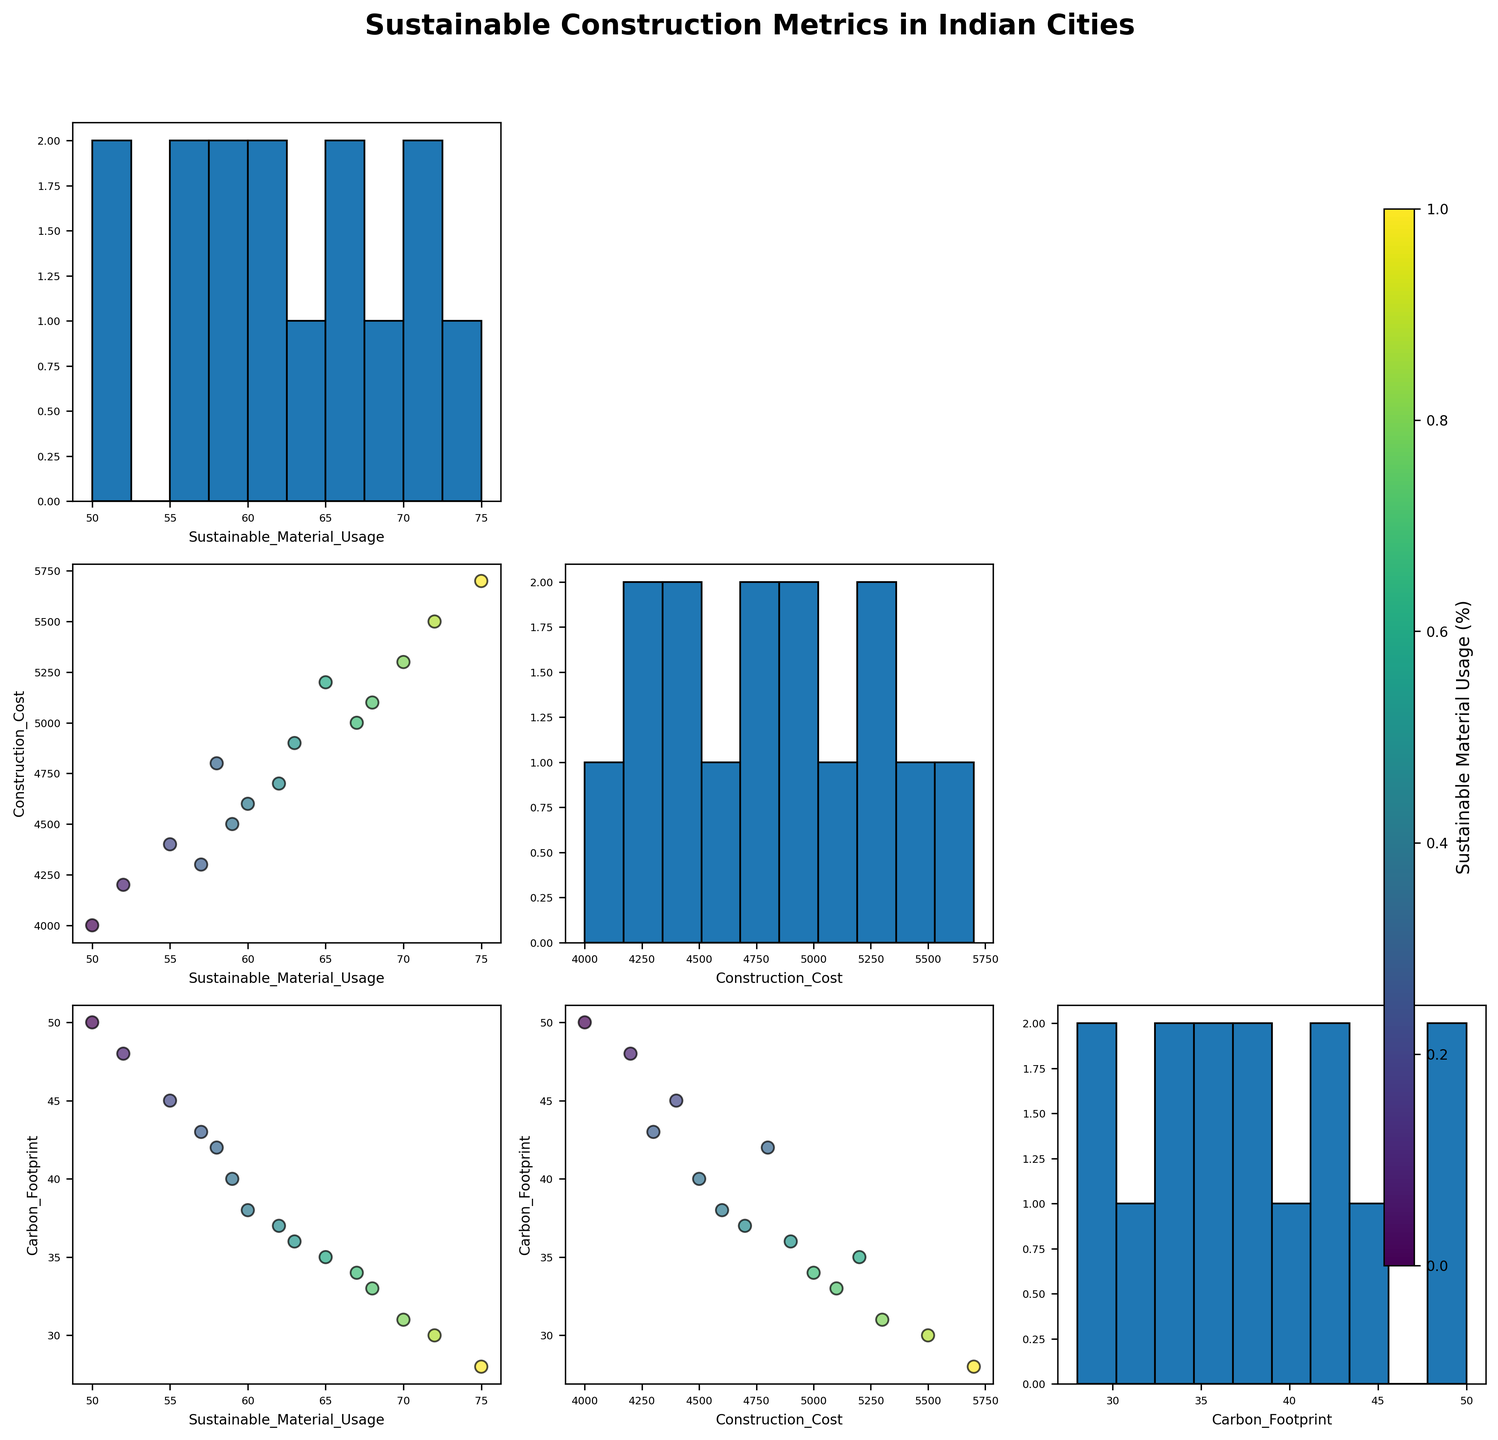What is the title of the figure? The title is usually mentioned at the top of the figure. In this case, it is "Sustainable Construction Metrics in Indian Cities".
Answer: Sustainable Construction Metrics in Indian Cities Which variable is represented by the color in the scatter plots? The color bar, shown separately with a label, indicates 'Sustainable Material Usage (%)'.
Answer: Sustainable Material Usage (%) How many cities are included in the dataset? By observing the figure, we can count the number of points or annotations (city names) present in the scatter plots. The figure has 15 cities labeled, from Mumbai to Nagpur.
Answer: 15 What is the scatter plot in the second row and the first column illustrating? The scatter plot in this position shows 'Construction Cost(INR/sqft)' on the x-axis and 'Sustainable Material Usage(%)' on the y-axis.
Answer: Construction Cost vs. Sustainable Material Usage Which city has the highest 'Sustainable Material Usage(%)' and what is its value? By looking at the color intensity corresponding to the highest value in the scatter plots or by identifying the outlier in histograms, Chandigarh has the highest 'Sustainable Material Usage' of 75%.
Answer: Chandigarh, 75% Is there a general trend between 'Construction Cost(INR/sqft)' and 'Carbon Footprint(kgCO2e/sqft)'? By observing the scatter plot for these two variables, it seems there is a positive correlation where higher construction costs tend to be associated with higher carbon footprints.
Answer: Positive correlation Which city has the lowest 'Carbon Footprint(kgCO2e/sqft)' and what is its value? By inspecting the scatter plots and identifying the lowest point on the Carbon Footprint axis, the city is Chandigarh with a value of 28 kgCO2e/sqft.
Answer: Chandigarh, 28 Comparing Mumbai and Pune, which city has a higher 'Sustainable Material Usage(%)'? From the annotations in the scatter plots, Mumbai has 65% while Pune has 70%, so Pune has a higher value.
Answer: Pune How does 'Carbon Footprint(kgCO2e/sqft)' generally change with increasing 'Sustainable Material Usage(%)'? One can notice a general downward trend in the scatter plots, indicating that as 'Sustainable Material Usage(%)' increases, the 'Carbon Footprint(kgCO2e/sqft)' tends to decrease.
Answer: Decreases What is the approximate 'Construction Cost(INR/sqft)' for cities with 'Sustainable Material Usage(%)' around 70%? By examining scatter plots and color intensities, cities Pune (70%) and Bangalore (72%) have construction costs of around 5300 and 5500 INR/sqft respectively.
Answer: Approximately 5300-5500 INR/sqft 